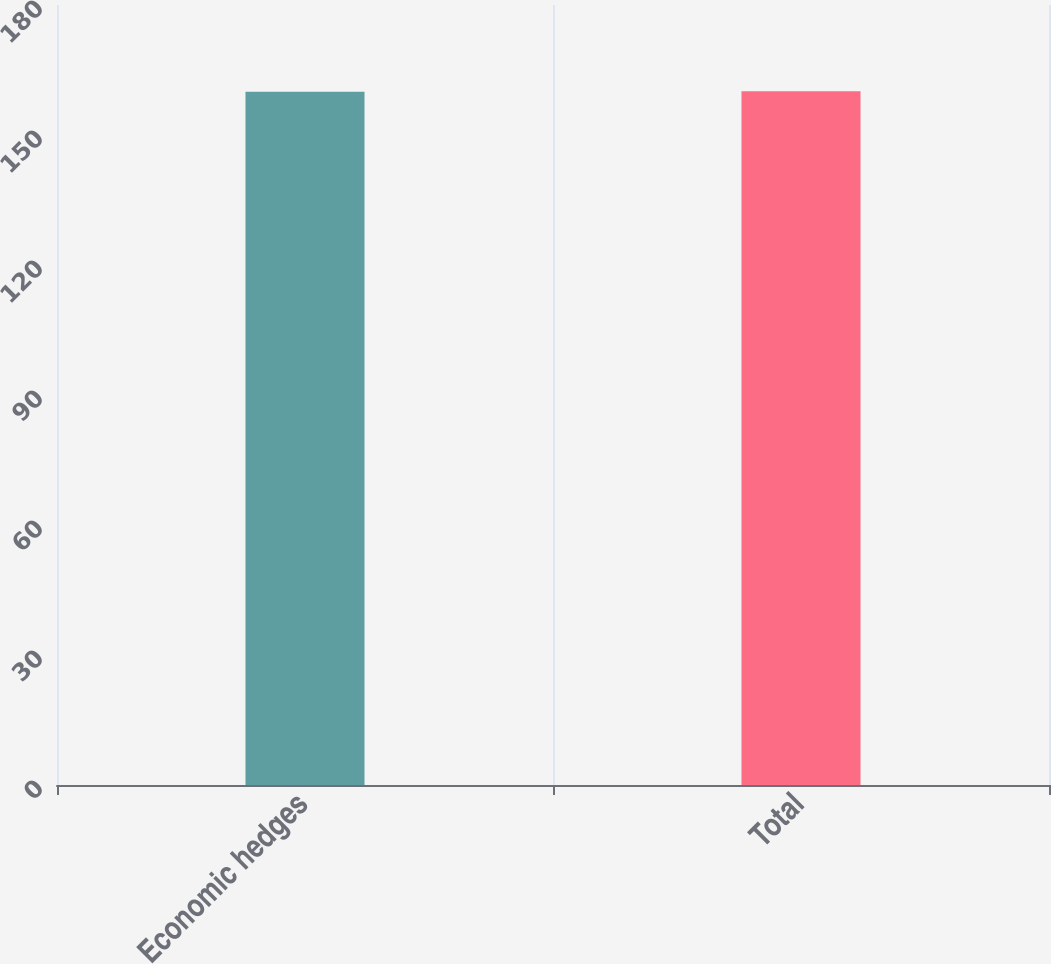<chart> <loc_0><loc_0><loc_500><loc_500><bar_chart><fcel>Economic hedges<fcel>Total<nl><fcel>160<fcel>160.1<nl></chart> 